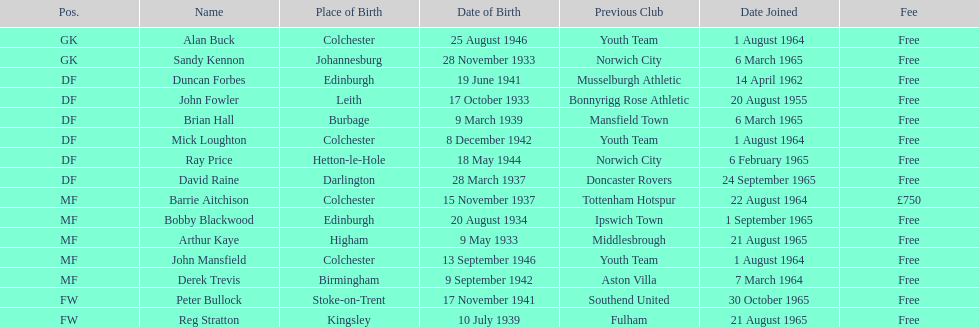Identify the player whose cost was not complimentary. Barrie Aitchison. 